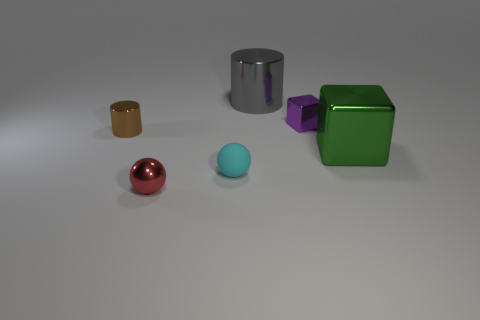What size is the red metallic ball?
Keep it short and to the point. Small. Does the purple metallic cube have the same size as the ball to the right of the red metallic thing?
Provide a succinct answer. Yes. How many gray things are either small cylinders or tiny metallic balls?
Your answer should be compact. 0. What number of big yellow shiny blocks are there?
Provide a short and direct response. 0. What size is the metallic thing in front of the small cyan matte sphere?
Offer a very short reply. Small. Does the purple shiny cube have the same size as the red metal object?
Give a very brief answer. Yes. How many objects are tiny purple things or things that are behind the green metallic thing?
Your response must be concise. 3. What is the material of the brown object?
Provide a succinct answer. Metal. Is there any other thing that has the same color as the tiny metal cube?
Keep it short and to the point. No. Does the small cyan thing have the same shape as the large gray metal thing?
Ensure brevity in your answer.  No. 